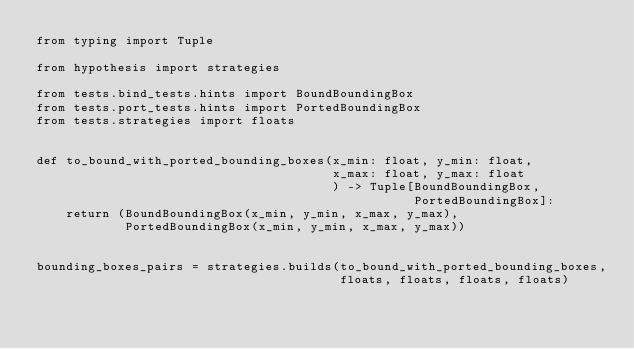Convert code to text. <code><loc_0><loc_0><loc_500><loc_500><_Python_>from typing import Tuple

from hypothesis import strategies

from tests.bind_tests.hints import BoundBoundingBox
from tests.port_tests.hints import PortedBoundingBox
from tests.strategies import floats


def to_bound_with_ported_bounding_boxes(x_min: float, y_min: float,
                                        x_max: float, y_max: float
                                        ) -> Tuple[BoundBoundingBox,
                                                   PortedBoundingBox]:
    return (BoundBoundingBox(x_min, y_min, x_max, y_max),
            PortedBoundingBox(x_min, y_min, x_max, y_max))


bounding_boxes_pairs = strategies.builds(to_bound_with_ported_bounding_boxes,
                                         floats, floats, floats, floats)
</code> 